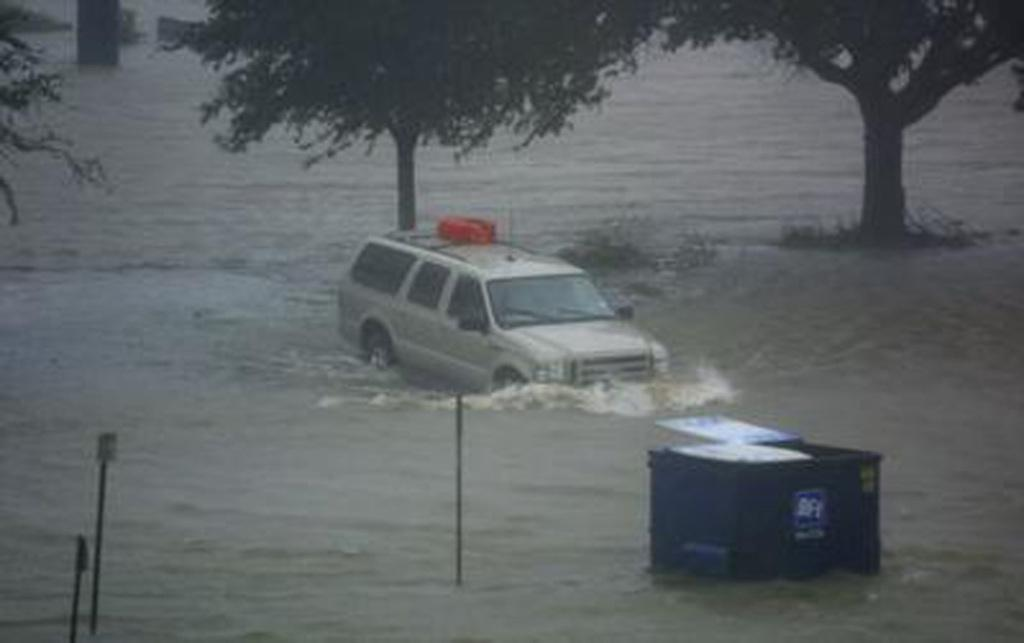What can be seen in the image that is not solid? There is water visible in the image. What are the poles in the image like in terms of color? The poles in the image are black colored. What type of object can be seen in the image that is used for transportation? There is a vehicle in the image. What is the color of the object that is partially submerged in the water? There is a blue colored object in the water. What is the side of the vehicle that is facing the water? The image does not provide enough information to determine which side of the vehicle is facing the water. How does the rain affect the visibility of the objects in the image? There is no mention of rain in the image, so its effect on visibility cannot be determined. 